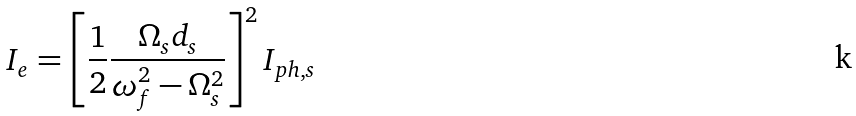Convert formula to latex. <formula><loc_0><loc_0><loc_500><loc_500>I _ { e } = \left [ \frac { 1 } { 2 } \frac { \Omega _ { s } d _ { s } } { \omega _ { f } ^ { 2 } - \Omega _ { s } ^ { 2 } } \right ] ^ { 2 } I _ { p h , s }</formula> 